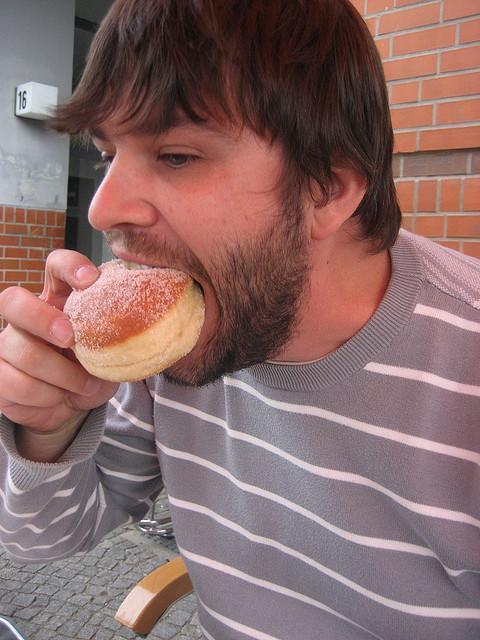Which character wears a shirt with a similar pattern to this man's shirt?
Pick the right solution, then justify: 'Answer: answer
Rationale: rationale.'
Options: Peter pan, linus, donald duck, daffy duck. Answer: linus.
Rationale: A man is wearing a gray shirt with white stripes. 